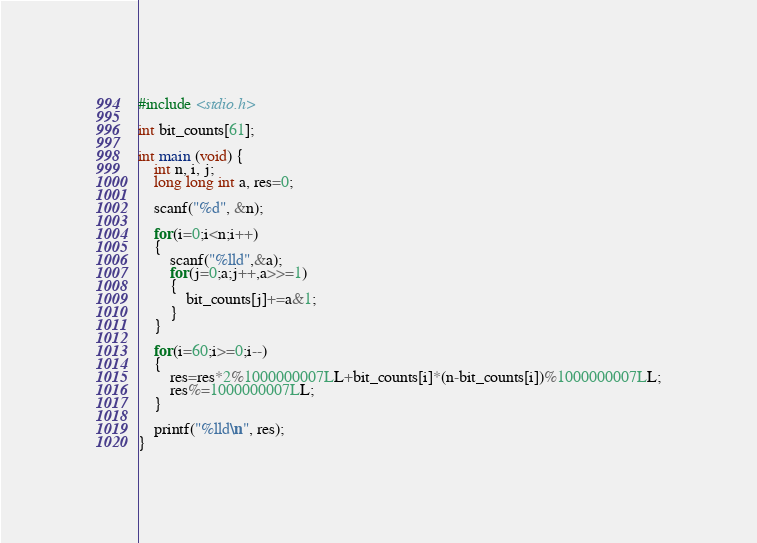Convert code to text. <code><loc_0><loc_0><loc_500><loc_500><_C_>#include <stdio.h>

int bit_counts[61];

int main (void) {
	int n, i, j;
	long long int a, res=0;
	
	scanf("%d", &n);
	
	for(i=0;i<n;i++)
	{
		scanf("%lld",&a);
		for(j=0;a;j++,a>>=1)
		{
			bit_counts[j]+=a&1;
		}
	}
	
	for(i=60;i>=0;i--)
	{
		res=res*2%1000000007LL+bit_counts[i]*(n-bit_counts[i])%1000000007LL;
		res%=1000000007LL;
	}
	
	printf("%lld\n", res);
}</code> 